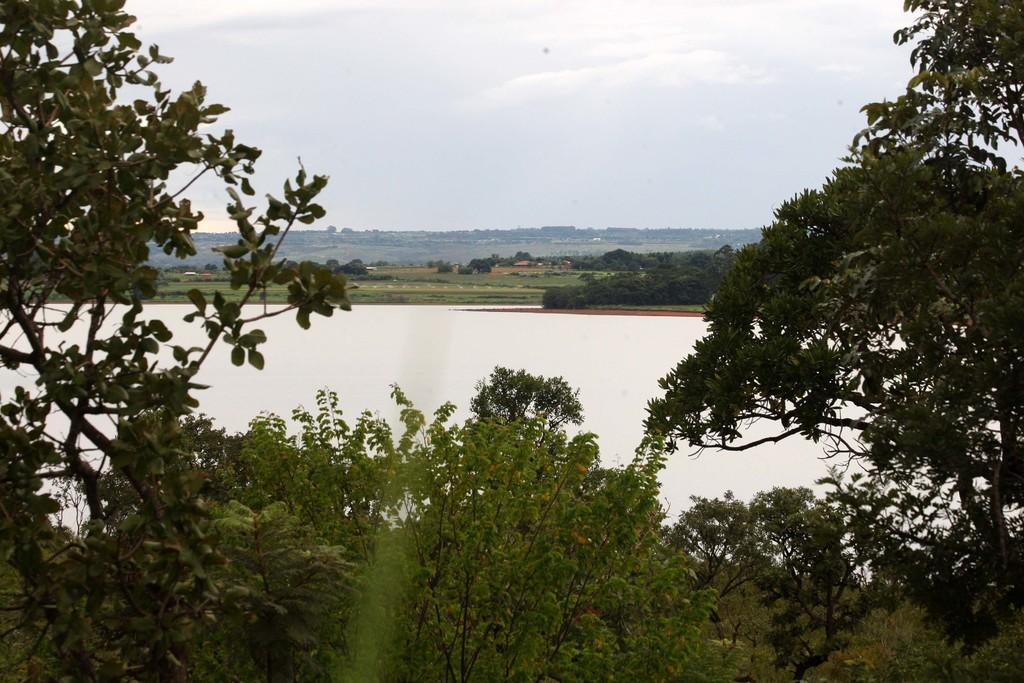What type of vegetation is present at the bottom of the image? There are trees and plants on the ground at the bottom of the image. What can be seen in the background of the image? There is water, trees, plants, and clouds in the background of the image. Can you describe the sky in the image? The sky in the background of the image contains clouds. Where is the toad hiding in the image? There is no toad present in the image. What type of air is visible in the image? The image does not show any specific type of air; it simply shows the sky with clouds. 